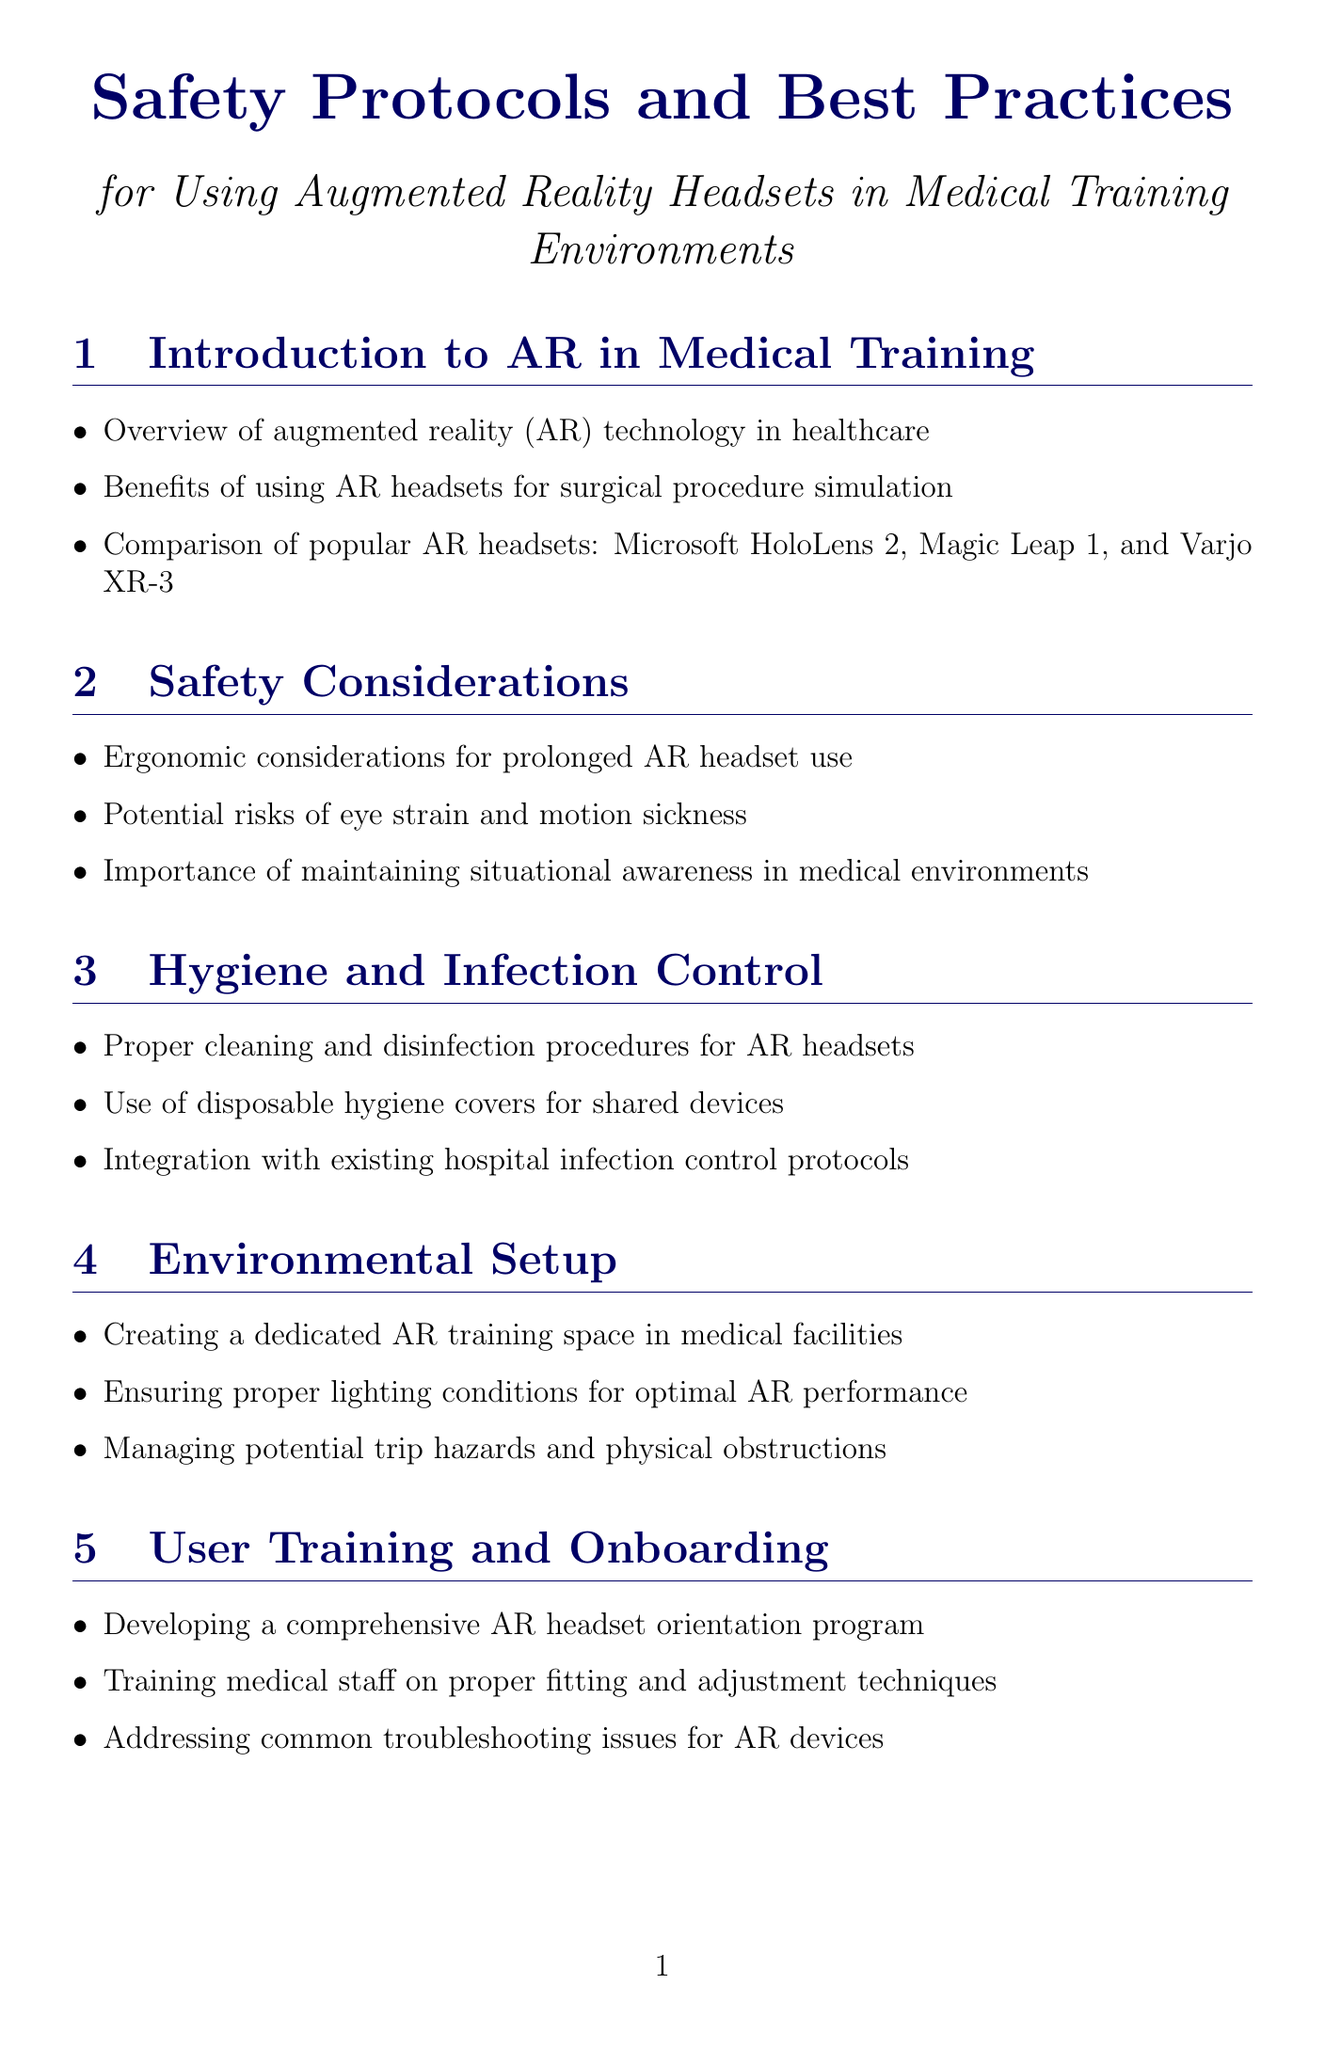What are the benefits of using AR headsets? The benefits are outlined in the section on augmented reality technology in healthcare, emphasizing their effectiveness for surgical procedure simulation.
Answer: Surgical procedure simulation What is a potential risk associated with AR headset use? The potential risks are detailed in the Safety Considerations section, which highlights eye strain and motion sickness.
Answer: Eye strain, motion sickness What should be ensured for optimal AR performance? This information is found in the Environmental Setup section, where proper lighting conditions are identified as crucial.
Answer: Proper lighting conditions What does HIPAA stand for in the context of AR-assisted training? The acronym is referred to in the Data Security and Patient Privacy section, specifically regarding compliance in medical training.
Answer: Health Insurance Portability and Accountability Act What is necessary when using AR headsets in sterile environments? This requirement is mentioned in the Integration with Existing Medical Equipment section, focusing on protocols.
Answer: Protocols for sterile environments How often should calibration checks for AR headsets be implemented? The Performance Monitoring and Quality Assurance section suggests a routine for maintaining device reliability through calibration checks.
Answer: Regular calibration checks What protocols should be developed for quick removal of AR headsets? This question is addressed in the Emergency Procedures section focusing on quick-removal protocols for emergencies.
Answer: Quick-removal protocols Which guidelines must be adhered to for medical training devices? The section on Regulatory Compliance and Documentation specifies adherence to certain guidelines for legal compliance.
Answer: FDA guidelines How should AR headsets be properly cleaned and disinfected? The Hygiene and Infection Control section outlines cleaning and disinfection procedures to ensure hygiene in medical settings.
Answer: Cleaning and disinfection procedures 